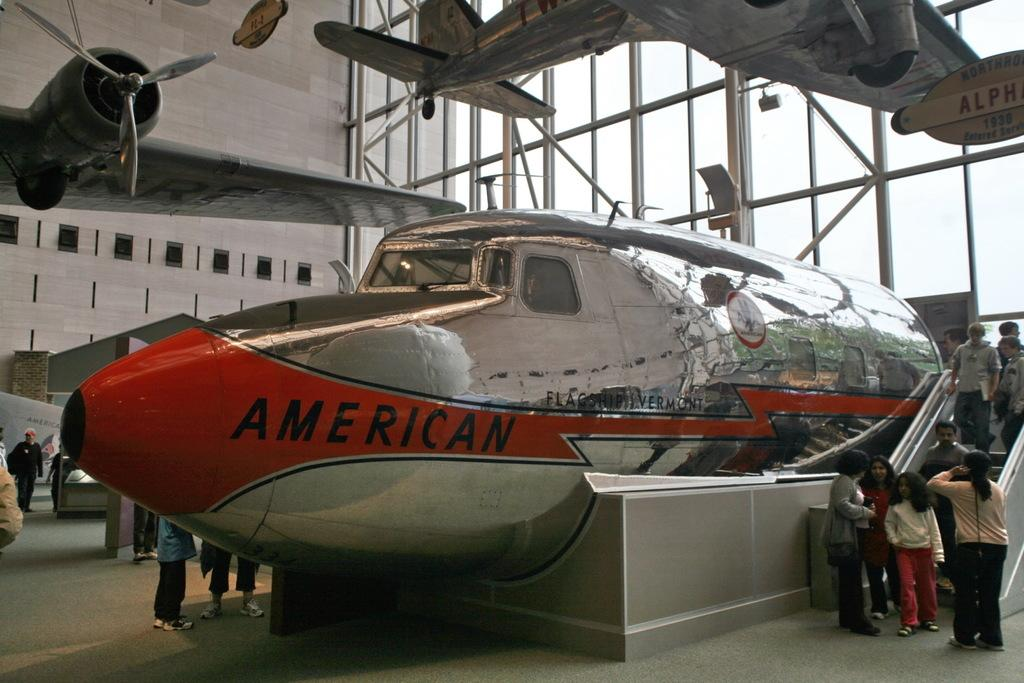<image>
Offer a succinct explanation of the picture presented. The front half of a silver and red plane that says American is sitting in a museum. 